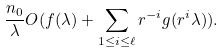Convert formula to latex. <formula><loc_0><loc_0><loc_500><loc_500>\frac { n _ { 0 } } { \lambda } O ( f ( \lambda ) + \sum _ { 1 \leq i \leq \ell } r ^ { - i } g ( r ^ { i } \lambda ) ) .</formula> 